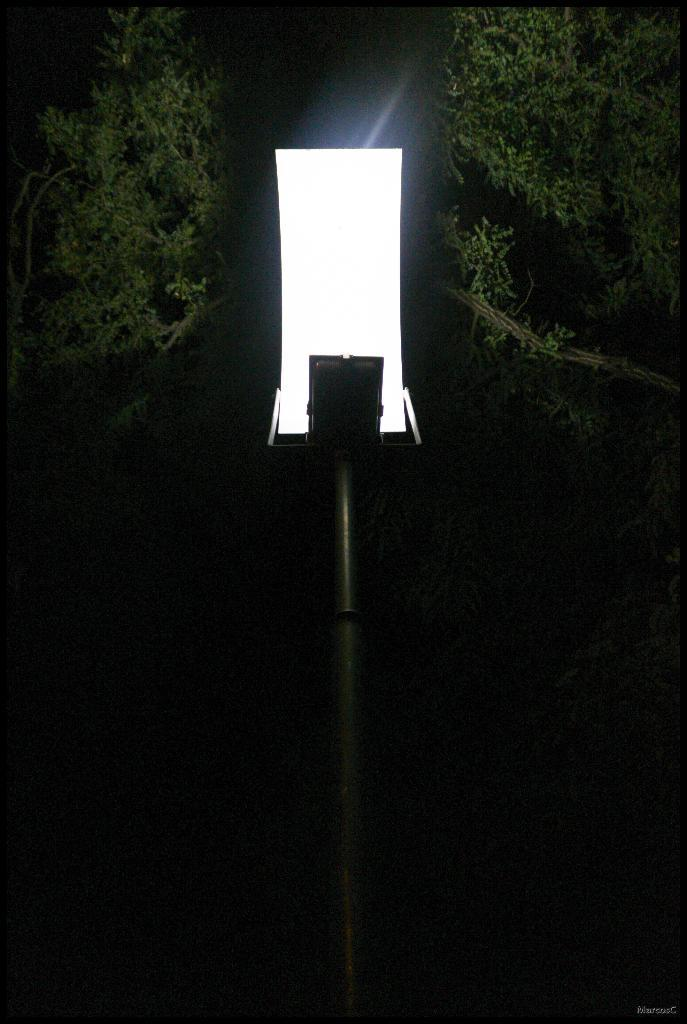What is the lighting condition in the image? The image was taken in the dark. What structure can be seen in the image? There is a light pole in the image. What type of vegetation is visible in the image? A few leaves are visible at the top of the image. What type of force is being exerted by the leaves in the image? There is no force being exerted by the leaves in the image; they are simply visible at the top of the image. 